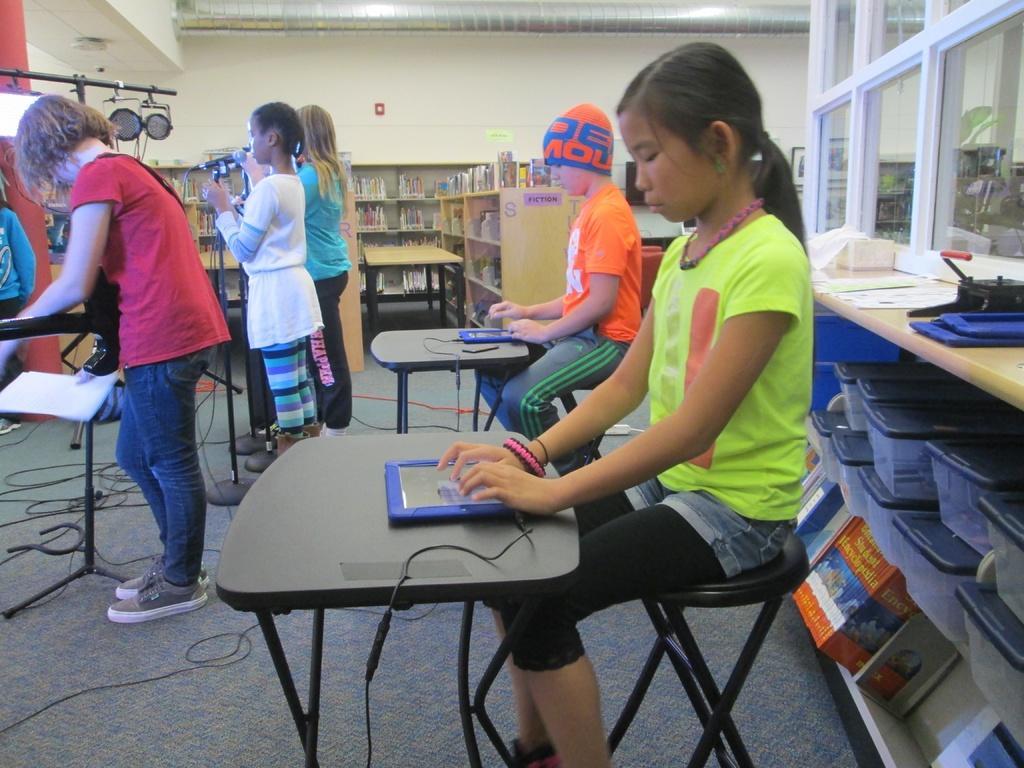In one or two sentences, can you explain what this image depicts? In this picture we can see inside view of the music training hall in which in front a girl wearing pink t- shirt and jeans standing and playing the guitar, beside a girl wearing white top and jeans is singing in the microphone, just beside her a another girl wearing blue color t-shirt is also singing. Behind a boy wearing orange t- shirt is sitting and playing the electronic piano and a girl beside him also playing the piano. Behind we can see the wooden shelves in which books and a glass window in the wall. 